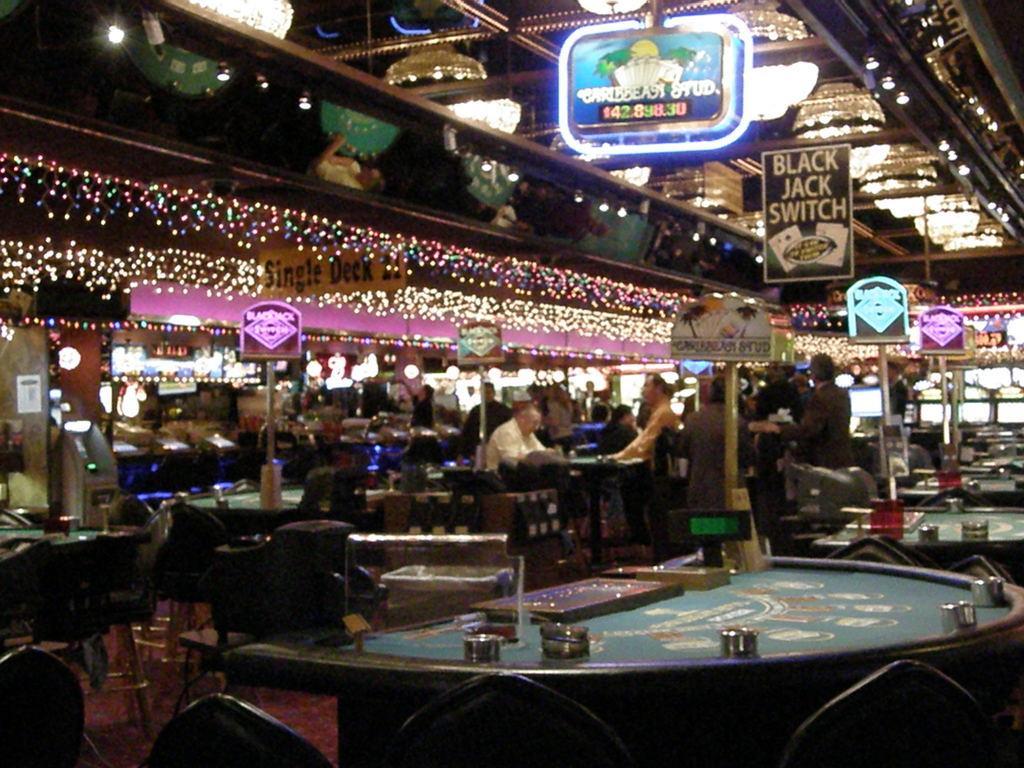In one or two sentences, can you explain what this image depicts? Here in the front we can see a casino table and there are chairs and tables present here and there and there are people Standing and sitting, there are lights all over the place, there are hoardings and there are chandeliers present 